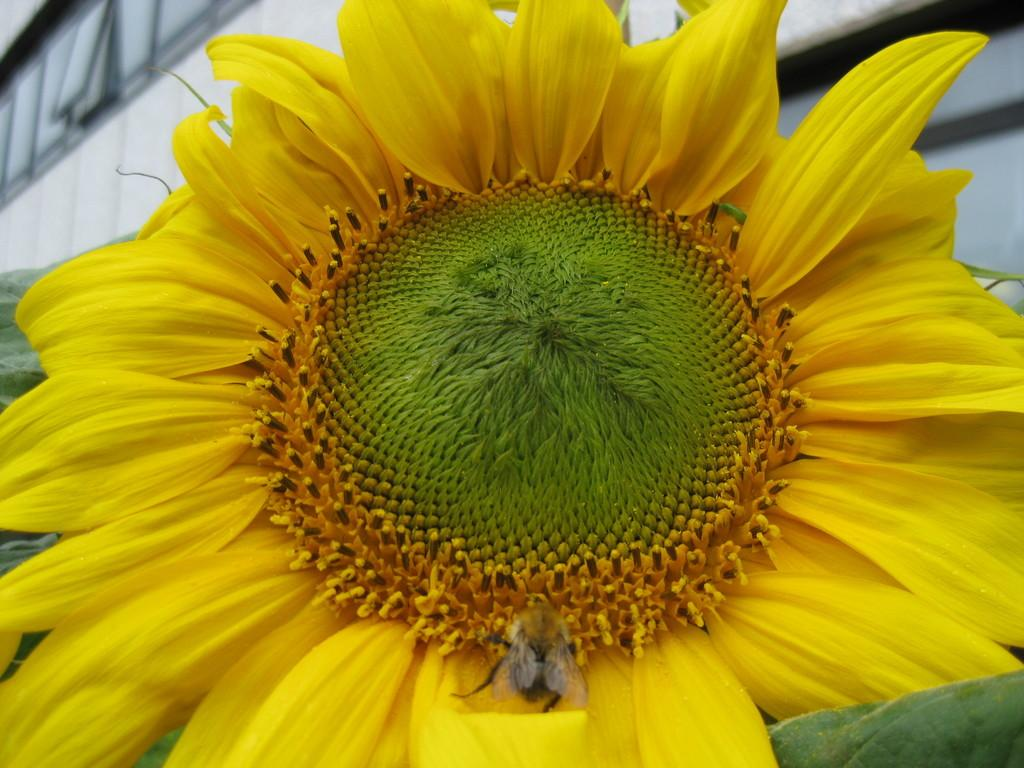What type of flower is present in the picture? There is a yellow flower in the picture. Is there any other living organism interacting with the flower? Yes, there is a honey bee on the flower. What can be seen in the background of the picture? There is a building visible in the background of the picture. Where is the drum located in the picture? There is no drum present in the picture. What type of cactus can be seen near the honey bee? There is no cactus present in the picture. 